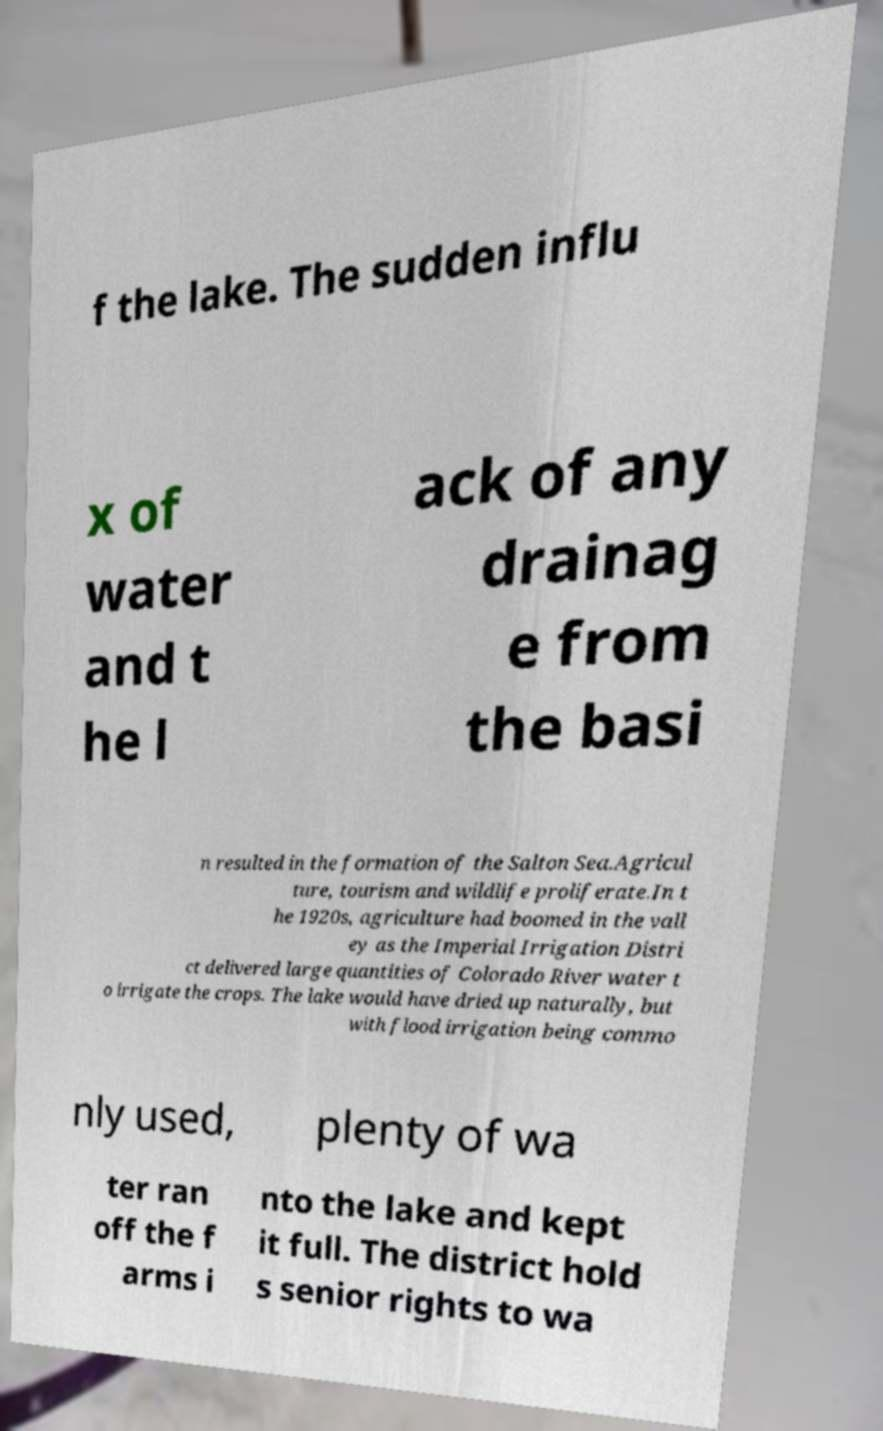I need the written content from this picture converted into text. Can you do that? f the lake. The sudden influ x of water and t he l ack of any drainag e from the basi n resulted in the formation of the Salton Sea.Agricul ture, tourism and wildlife proliferate.In t he 1920s, agriculture had boomed in the vall ey as the Imperial Irrigation Distri ct delivered large quantities of Colorado River water t o irrigate the crops. The lake would have dried up naturally, but with flood irrigation being commo nly used, plenty of wa ter ran off the f arms i nto the lake and kept it full. The district hold s senior rights to wa 